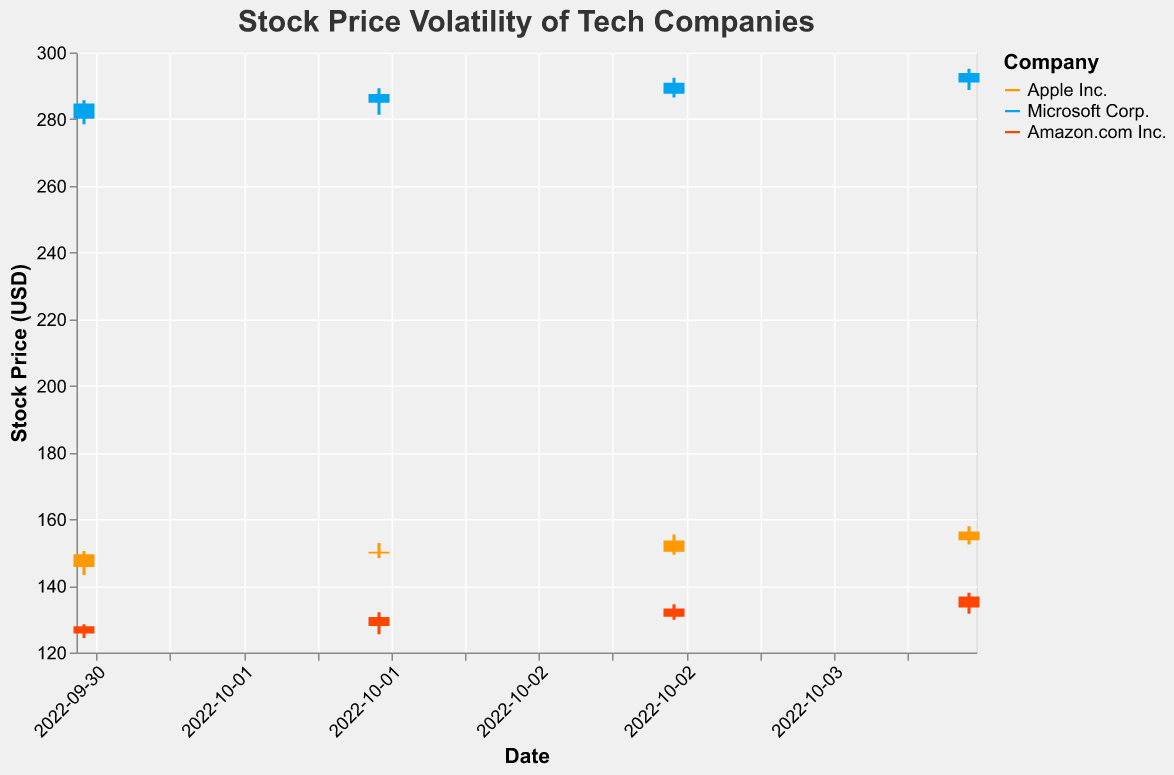What is the title of the plot? The title is located at the top of the figure in a larger font.
Answer: Stock Price Volatility of Tech Companies Which company's stock color is represented by the shade of blue? By referencing the legend on the right-hand side of the plot, "Microsoft Corp." is represented by the shade of blue.
Answer: Microsoft Corp On which date did Amazon.com Inc. have the highest closing stock price? By observing the candlestick plot for each date for Amazon.com Inc., the closing price on 2022-10-04 is the highest.
Answer: 2022-10-04 What is the range (high minus low) of Apple's stock price on 2022-10-03? On 2022-10-03, Apple's high price was 155.42 and the low price was 149.32. The range is calculated as 155.42 - 149.32.
Answer: 6.10 Which company had the highest opening stock price on 2022-10-01? By examining the opening prices for each company on 2022-10-01, Microsoft Corp. opened at 280.12, which is higher than Apple Inc. and Amazon.com Inc.
Answer: Microsoft Corp What is the average closing price of Microsoft Corp. over the displayed dates? Sum the closing prices of Microsoft Corp. (284.73, 287.52, 290.91, 293.85) and divide by the number of dates. (284.73 + 287.52 + 290.91 + 293.85) / 4 = 289.75
Answer: 289.75 Which company exhibited the highest volatility in stock prices based on the ranges? Calculate the range (High - Low) for each company and compare. Apple Inc. ranges: 7.24, 4.50, 6.10, 5.41. Microsoft Corp. ranges: 7.24, 7.99, 5.92, 6.36. Amazon.com Inc. ranges: 4.13, 6.55, 4.68, 6.25. Microsoft shows the highest single day range: 7.99.
Answer: Microsoft Corp How did Amazon.com Inc.'s closing price trend over the given dates? Observe the closing prices of Amazon.com Inc. over the 4 days: 127.85, 130.67, 133.22, and 136.77. Each day's closing price is higher than the previous day's.
Answer: Increasing trend Which date saw the greatest fluctuation in stock prices for all companies combined? Calculate the sum of ranges (High - Low) for each date, then compare across dates. 2022-10-01: 7.24 (Apple) + 7.24 (Microsoft) + 4.13 (Amazon) = 18.61. Similar calculations show the highest fluctuation on 2022-10-02 with a sum range of 19.04.
Answer: 2022-10-02 